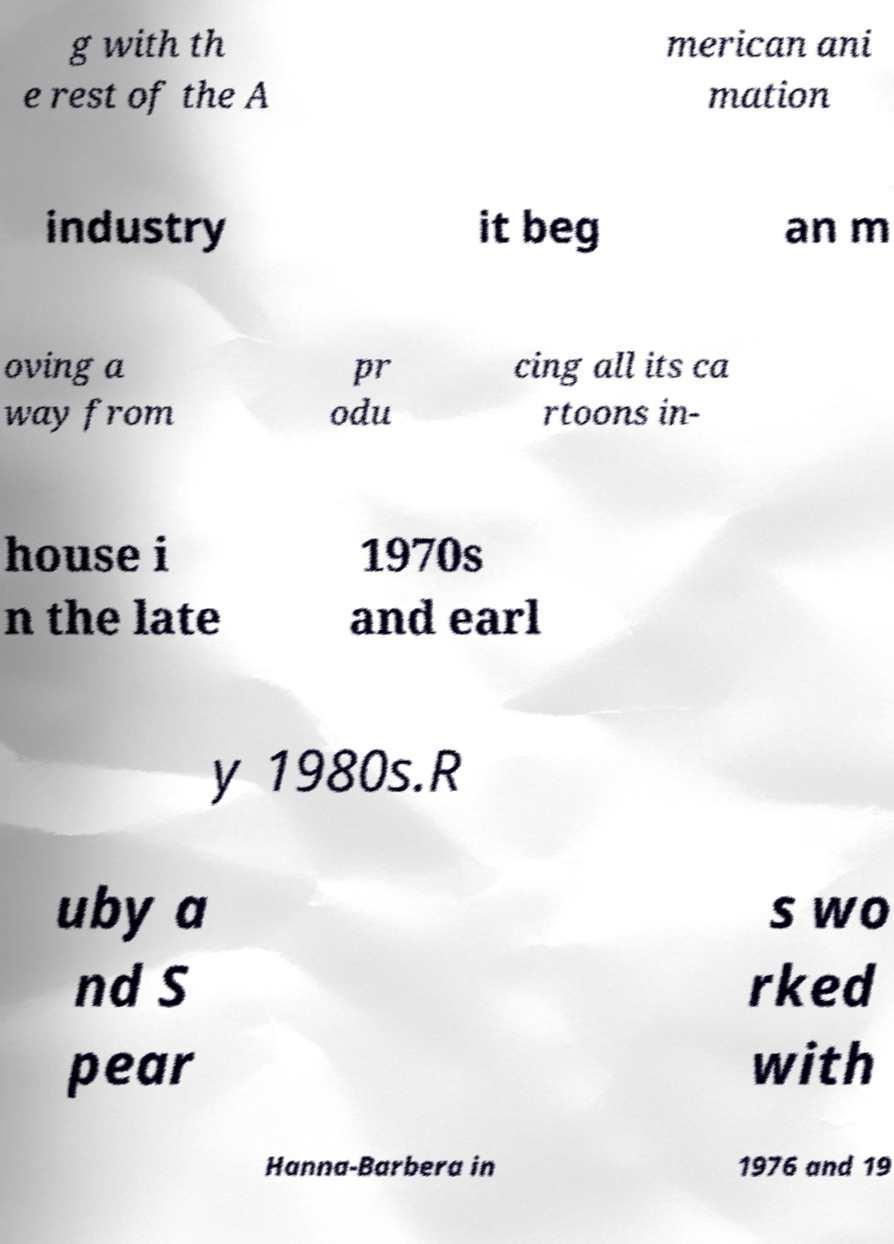Please identify and transcribe the text found in this image. g with th e rest of the A merican ani mation industry it beg an m oving a way from pr odu cing all its ca rtoons in- house i n the late 1970s and earl y 1980s.R uby a nd S pear s wo rked with Hanna-Barbera in 1976 and 19 